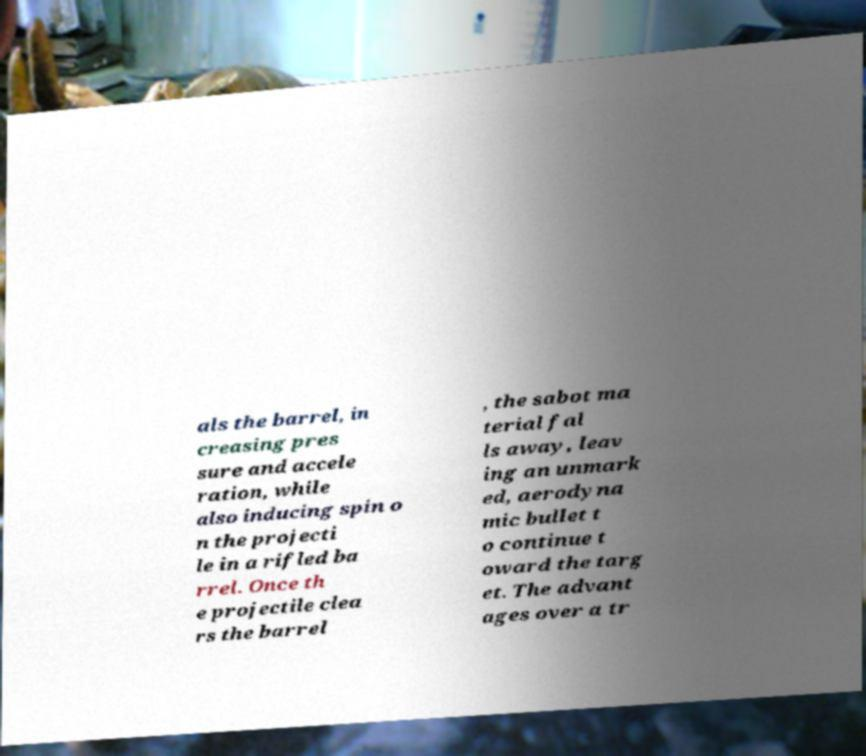Can you read and provide the text displayed in the image?This photo seems to have some interesting text. Can you extract and type it out for me? als the barrel, in creasing pres sure and accele ration, while also inducing spin o n the projecti le in a rifled ba rrel. Once th e projectile clea rs the barrel , the sabot ma terial fal ls away, leav ing an unmark ed, aerodyna mic bullet t o continue t oward the targ et. The advant ages over a tr 